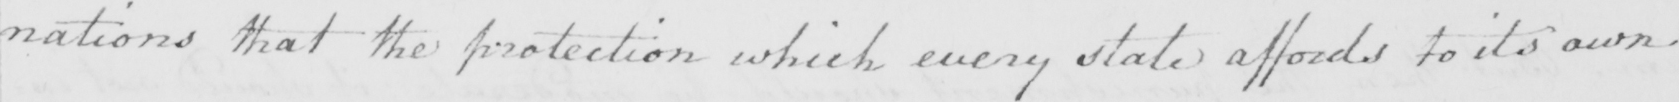What does this handwritten line say? nations that the protection which every state affords to its own 